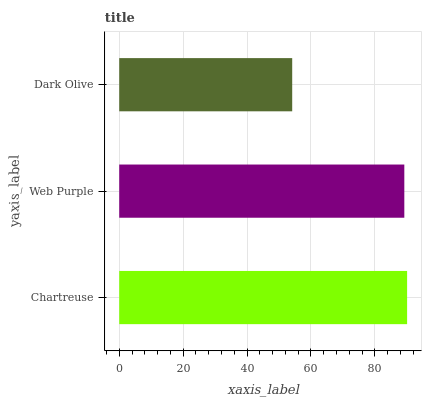Is Dark Olive the minimum?
Answer yes or no. Yes. Is Chartreuse the maximum?
Answer yes or no. Yes. Is Web Purple the minimum?
Answer yes or no. No. Is Web Purple the maximum?
Answer yes or no. No. Is Chartreuse greater than Web Purple?
Answer yes or no. Yes. Is Web Purple less than Chartreuse?
Answer yes or no. Yes. Is Web Purple greater than Chartreuse?
Answer yes or no. No. Is Chartreuse less than Web Purple?
Answer yes or no. No. Is Web Purple the high median?
Answer yes or no. Yes. Is Web Purple the low median?
Answer yes or no. Yes. Is Dark Olive the high median?
Answer yes or no. No. Is Dark Olive the low median?
Answer yes or no. No. 